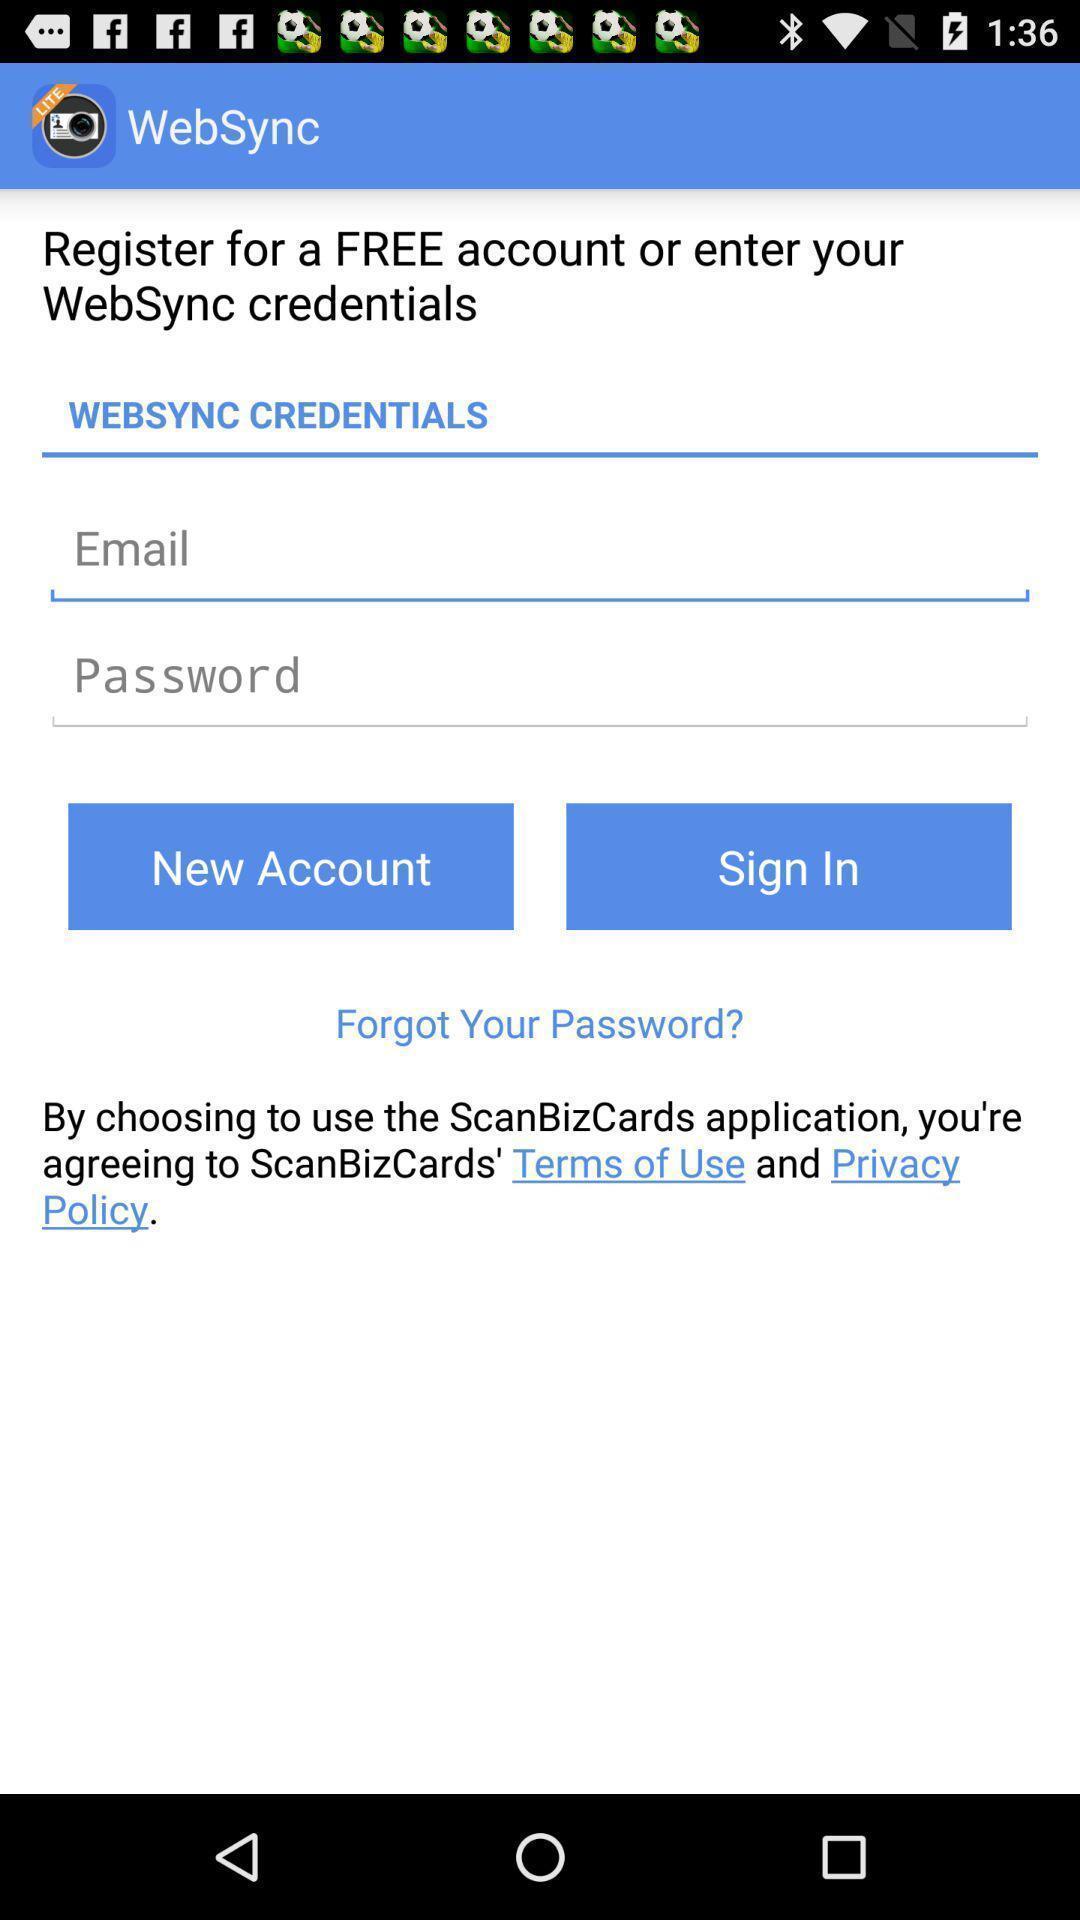Give me a narrative description of this picture. Sign in page. 